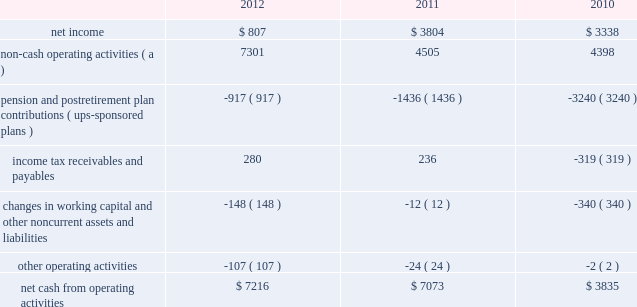United parcel service , inc .
And subsidiaries management's discussion and analysis of financial condition and results of operations liquidity and capital resources operating activities the following is a summary of the significant sources ( uses ) of cash from operating activities ( amounts in millions ) : .
( a ) represents depreciation and amortization , gains and losses on derivative and foreign exchange transactions , deferred income taxes , provisions for uncollectible accounts , pension and postretirement benefit expense , stock compensation expense , impairment charges and other non-cash items .
Cash from operating activities remained strong throughout the 2010 to 2012 time period .
Operating cash flow was favorably impacted in 2012 , compared with 2011 , by lower contributions into our defined benefit pension and postretirement benefit plans ; however , this was partially offset by changes in our working capital position , which was impacted by overall growth in the business .
The change in the cash flows for income tax receivables and payables in 2011 and 2010 was primarily related to the timing of discretionary pension contributions during 2010 , as discussed further in the following paragraph .
Except for discretionary or accelerated fundings of our plans , contributions to our company-sponsored pension plans have largely varied based on whether any minimum funding requirements are present for individual pension plans .
2022 in 2012 , we made a $ 355 million required contribution to the ups ibt pension plan .
2022 in 2011 , we made a $ 1.2 billion contribution to the ups ibt pension plan , which satisfied our 2011 contribution requirements and also approximately $ 440 million in contributions that would not have been required until after 2011 .
2022 in 2010 , we made $ 2.0 billion in discretionary contributions to our ups retirement and ups pension plans , and $ 980 million in required contributions to our ups ibt pension plan .
2022 the remaining contributions in the 2010 through 2012 period were largely due to contributions to our international pension plans and u.s .
Postretirement medical benefit plans .
As discussed further in the 201ccontractual commitments 201d section , we have minimum funding requirements in the next several years , primarily related to the ups ibt pension , ups retirement and ups pension plans .
As of december 31 , 2012 , the total of our worldwide holdings of cash and cash equivalents was $ 7.327 billion .
Approximately $ 4.211 billion of this amount was held in european subsidiaries with the intended purpose of completing the acquisition of tnt express n.v .
( see note 16 to the consolidated financial statements ) .
Excluding this portion of cash held outside the u.s .
For acquisition-related purposes , approximately 50%-60% ( 50%-60 % ) of the remaining cash and cash equivalents are held by foreign subsidiaries throughout the year .
The amount of cash held by our u.s .
And foreign subsidiaries fluctuates throughout the year due to a variety of factors , including the timing of cash receipts and disbursements in the normal course of business .
Cash provided by operating activities in the united states continues to be our primary source of funds to finance domestic operating needs , capital expenditures , share repurchases and dividend payments to shareowners .
To the extent that such amounts represent previously untaxed earnings , the cash held by foreign subsidiaries would be subject to tax if such amounts were repatriated in the form of dividends ; however , not all international cash balances would have to be repatriated in the form of a dividend if returned to the u.s .
When amounts earned by foreign subsidiaries are expected to be indefinitely reinvested , no accrual for taxes is provided. .
What is the percentage change in net cash from operating activities from 2011 to 2012? 
Computations: ((7073 - 7216) / 7216)
Answer: -0.01982. 